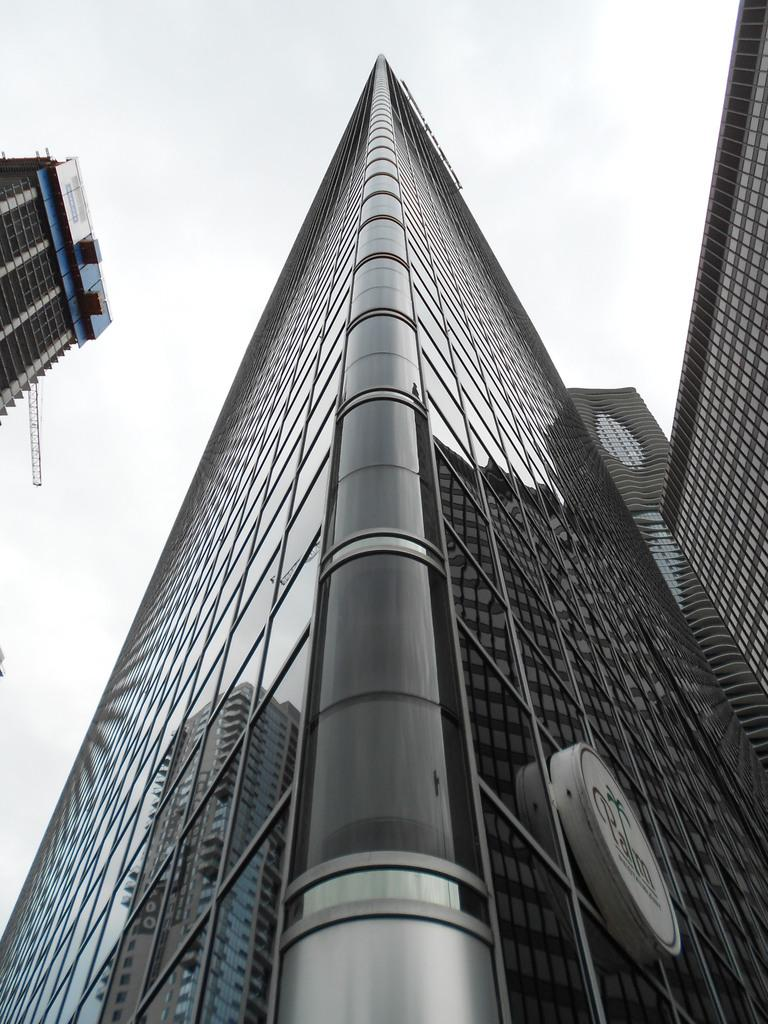What type of structures are present in the image? There are big buildings in the image. What can be seen in the sky in the image? The sky is full of clouds. What type of connection can be seen between the buildings in the image? There is no specific connection between the buildings mentioned in the image. How many feet are visible in the image? There is no mention of feet or any human presence in the image. 